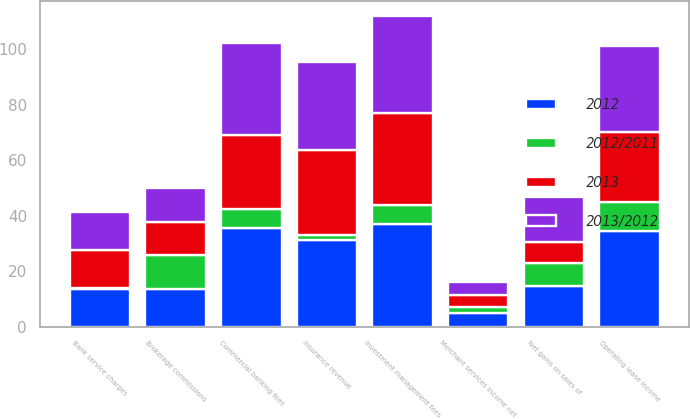Convert chart. <chart><loc_0><loc_0><loc_500><loc_500><stacked_bar_chart><ecel><fcel>Bank service charges<fcel>Investment management fees<fcel>Operating lease income<fcel>Insurance revenue<fcel>Net gains on sales of<fcel>Brokerage commissions<fcel>Commercial banking fees<fcel>Merchant services income net<nl><fcel>2012<fcel>13.7<fcel>37.2<fcel>34.5<fcel>31.2<fcel>14.8<fcel>13.7<fcel>35.6<fcel>5<nl><fcel>2013/2012<fcel>13.7<fcel>34.9<fcel>31.2<fcel>31.8<fcel>16.1<fcel>12.2<fcel>33.3<fcel>4.9<nl><fcel>2013<fcel>13.7<fcel>33.2<fcel>25<fcel>30.7<fcel>7.6<fcel>11.9<fcel>26.6<fcel>4.3<nl><fcel>2012/2011<fcel>0.1<fcel>6.6<fcel>10.6<fcel>1.9<fcel>8.1<fcel>12.3<fcel>6.9<fcel>2<nl></chart> 